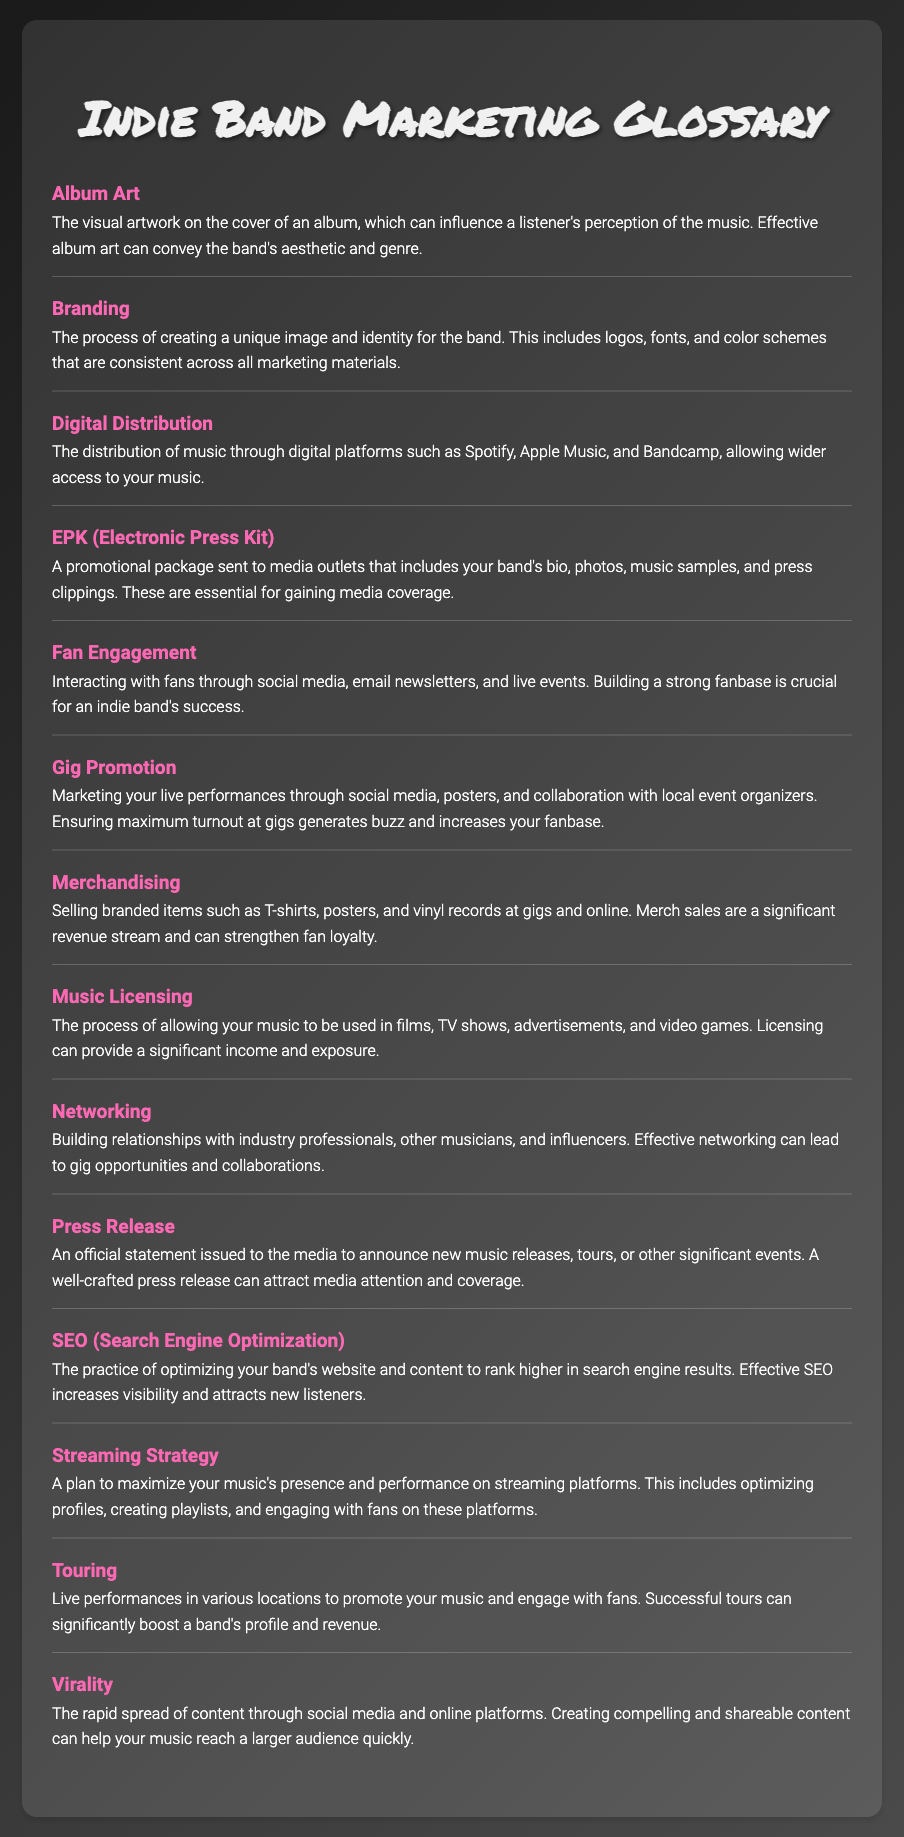What is Album Art? Album Art is defined as the visual artwork on the cover of an album, which can influence a listener's perception of the music.
Answer: Visual artwork on the cover What does Branding entail? Branding involves creating a unique image and identity for the band, including logos, fonts, and color schemes that are consistent across all marketing materials.
Answer: Unique image and identity What is an EPK? An EPK, or Electronic Press Kit, is a promotional package including the band's bio, photos, music samples, and press clippings.
Answer: Promotional package What does Fan Engagement involve? Fan Engagement involves interacting with fans through social media, email newsletters, and live events, which is crucial for success.
Answer: Interacting with fans What is the purpose of Music Licensing? The purpose of Music Licensing is to allow a band's music to be used in films, TV shows, advertisements, and video games.
Answer: Allow music usage What is one benefit of effective Networking? Effective Networking can lead to gig opportunities and collaborations.
Answer: Gig opportunities What is a well-crafted Press Release meant to do? A well-crafted Press Release is meant to attract media attention and coverage.
Answer: Attract media attention What practice does SEO refer to? SEO refers to the practice of optimizing a band's website and content to rank higher in search engine results.
Answer: Optimizing website and content What is the focus of a Streaming Strategy? A Streaming Strategy focuses on maximizing music's presence and performance on streaming platforms.
Answer: Maximizing presence and performance 